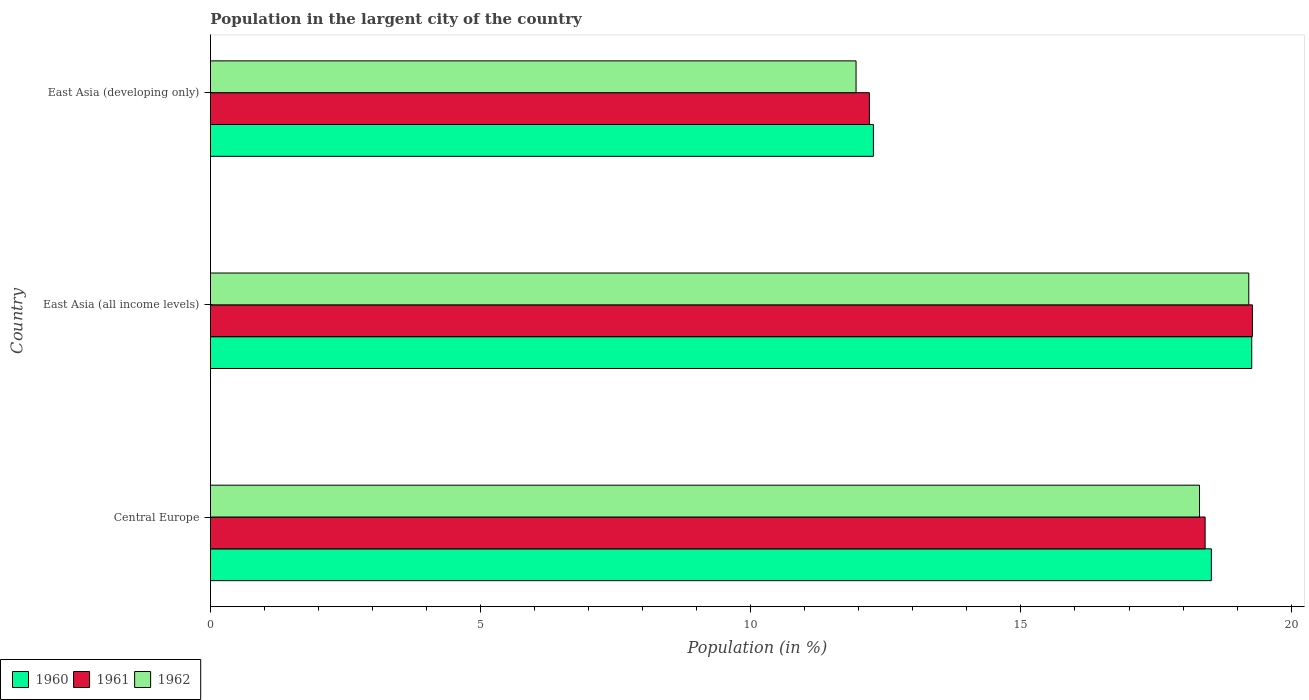How many different coloured bars are there?
Keep it short and to the point. 3. How many bars are there on the 3rd tick from the top?
Offer a terse response. 3. What is the label of the 2nd group of bars from the top?
Make the answer very short. East Asia (all income levels). In how many cases, is the number of bars for a given country not equal to the number of legend labels?
Offer a terse response. 0. What is the percentage of population in the largent city in 1962 in East Asia (developing only)?
Make the answer very short. 11.95. Across all countries, what is the maximum percentage of population in the largent city in 1960?
Give a very brief answer. 19.27. Across all countries, what is the minimum percentage of population in the largent city in 1962?
Keep it short and to the point. 11.95. In which country was the percentage of population in the largent city in 1960 maximum?
Give a very brief answer. East Asia (all income levels). In which country was the percentage of population in the largent city in 1961 minimum?
Ensure brevity in your answer.  East Asia (developing only). What is the total percentage of population in the largent city in 1961 in the graph?
Give a very brief answer. 49.89. What is the difference between the percentage of population in the largent city in 1960 in Central Europe and that in East Asia (developing only)?
Make the answer very short. 6.25. What is the difference between the percentage of population in the largent city in 1960 in East Asia (all income levels) and the percentage of population in the largent city in 1962 in Central Europe?
Your answer should be compact. 0.97. What is the average percentage of population in the largent city in 1961 per country?
Give a very brief answer. 16.63. What is the difference between the percentage of population in the largent city in 1961 and percentage of population in the largent city in 1962 in East Asia (all income levels)?
Your answer should be compact. 0.07. What is the ratio of the percentage of population in the largent city in 1962 in Central Europe to that in East Asia (all income levels)?
Your answer should be compact. 0.95. Is the difference between the percentage of population in the largent city in 1961 in Central Europe and East Asia (developing only) greater than the difference between the percentage of population in the largent city in 1962 in Central Europe and East Asia (developing only)?
Offer a very short reply. No. What is the difference between the highest and the second highest percentage of population in the largent city in 1960?
Ensure brevity in your answer.  0.75. What is the difference between the highest and the lowest percentage of population in the largent city in 1962?
Your answer should be compact. 7.27. In how many countries, is the percentage of population in the largent city in 1961 greater than the average percentage of population in the largent city in 1961 taken over all countries?
Your answer should be compact. 2. What does the 2nd bar from the top in East Asia (all income levels) represents?
Ensure brevity in your answer.  1961. What does the 3rd bar from the bottom in East Asia (all income levels) represents?
Offer a terse response. 1962. Are all the bars in the graph horizontal?
Your answer should be very brief. Yes. How many countries are there in the graph?
Your answer should be compact. 3. What is the difference between two consecutive major ticks on the X-axis?
Your answer should be compact. 5. Does the graph contain any zero values?
Offer a very short reply. No. Where does the legend appear in the graph?
Make the answer very short. Bottom left. How are the legend labels stacked?
Provide a short and direct response. Horizontal. What is the title of the graph?
Ensure brevity in your answer.  Population in the largent city of the country. Does "1990" appear as one of the legend labels in the graph?
Keep it short and to the point. No. What is the label or title of the X-axis?
Offer a very short reply. Population (in %). What is the Population (in %) in 1960 in Central Europe?
Provide a short and direct response. 18.52. What is the Population (in %) of 1961 in Central Europe?
Provide a succinct answer. 18.41. What is the Population (in %) in 1962 in Central Europe?
Your response must be concise. 18.31. What is the Population (in %) in 1960 in East Asia (all income levels)?
Keep it short and to the point. 19.27. What is the Population (in %) in 1961 in East Asia (all income levels)?
Ensure brevity in your answer.  19.28. What is the Population (in %) of 1962 in East Asia (all income levels)?
Give a very brief answer. 19.22. What is the Population (in %) of 1960 in East Asia (developing only)?
Your answer should be compact. 12.27. What is the Population (in %) of 1961 in East Asia (developing only)?
Offer a terse response. 12.2. What is the Population (in %) of 1962 in East Asia (developing only)?
Make the answer very short. 11.95. Across all countries, what is the maximum Population (in %) of 1960?
Keep it short and to the point. 19.27. Across all countries, what is the maximum Population (in %) in 1961?
Offer a very short reply. 19.28. Across all countries, what is the maximum Population (in %) of 1962?
Offer a very short reply. 19.22. Across all countries, what is the minimum Population (in %) in 1960?
Your answer should be very brief. 12.27. Across all countries, what is the minimum Population (in %) in 1961?
Offer a very short reply. 12.2. Across all countries, what is the minimum Population (in %) in 1962?
Your answer should be compact. 11.95. What is the total Population (in %) in 1960 in the graph?
Provide a short and direct response. 50.07. What is the total Population (in %) in 1961 in the graph?
Make the answer very short. 49.89. What is the total Population (in %) of 1962 in the graph?
Your answer should be compact. 49.47. What is the difference between the Population (in %) in 1960 in Central Europe and that in East Asia (all income levels)?
Your answer should be very brief. -0.75. What is the difference between the Population (in %) in 1961 in Central Europe and that in East Asia (all income levels)?
Ensure brevity in your answer.  -0.87. What is the difference between the Population (in %) in 1962 in Central Europe and that in East Asia (all income levels)?
Your response must be concise. -0.91. What is the difference between the Population (in %) in 1960 in Central Europe and that in East Asia (developing only)?
Provide a succinct answer. 6.25. What is the difference between the Population (in %) of 1961 in Central Europe and that in East Asia (developing only)?
Provide a succinct answer. 6.21. What is the difference between the Population (in %) in 1962 in Central Europe and that in East Asia (developing only)?
Give a very brief answer. 6.36. What is the difference between the Population (in %) in 1960 in East Asia (all income levels) and that in East Asia (developing only)?
Provide a succinct answer. 7. What is the difference between the Population (in %) of 1961 in East Asia (all income levels) and that in East Asia (developing only)?
Your answer should be compact. 7.09. What is the difference between the Population (in %) of 1962 in East Asia (all income levels) and that in East Asia (developing only)?
Make the answer very short. 7.27. What is the difference between the Population (in %) of 1960 in Central Europe and the Population (in %) of 1961 in East Asia (all income levels)?
Your response must be concise. -0.76. What is the difference between the Population (in %) of 1960 in Central Europe and the Population (in %) of 1962 in East Asia (all income levels)?
Offer a very short reply. -0.69. What is the difference between the Population (in %) in 1961 in Central Europe and the Population (in %) in 1962 in East Asia (all income levels)?
Provide a succinct answer. -0.81. What is the difference between the Population (in %) in 1960 in Central Europe and the Population (in %) in 1961 in East Asia (developing only)?
Make the answer very short. 6.33. What is the difference between the Population (in %) of 1960 in Central Europe and the Population (in %) of 1962 in East Asia (developing only)?
Keep it short and to the point. 6.58. What is the difference between the Population (in %) in 1961 in Central Europe and the Population (in %) in 1962 in East Asia (developing only)?
Ensure brevity in your answer.  6.46. What is the difference between the Population (in %) of 1960 in East Asia (all income levels) and the Population (in %) of 1961 in East Asia (developing only)?
Your answer should be compact. 7.08. What is the difference between the Population (in %) of 1960 in East Asia (all income levels) and the Population (in %) of 1962 in East Asia (developing only)?
Make the answer very short. 7.32. What is the difference between the Population (in %) in 1961 in East Asia (all income levels) and the Population (in %) in 1962 in East Asia (developing only)?
Your answer should be compact. 7.34. What is the average Population (in %) in 1960 per country?
Your answer should be very brief. 16.69. What is the average Population (in %) in 1961 per country?
Provide a short and direct response. 16.63. What is the average Population (in %) of 1962 per country?
Give a very brief answer. 16.49. What is the difference between the Population (in %) in 1960 and Population (in %) in 1961 in Central Europe?
Ensure brevity in your answer.  0.12. What is the difference between the Population (in %) of 1960 and Population (in %) of 1962 in Central Europe?
Your response must be concise. 0.22. What is the difference between the Population (in %) in 1961 and Population (in %) in 1962 in Central Europe?
Ensure brevity in your answer.  0.1. What is the difference between the Population (in %) in 1960 and Population (in %) in 1961 in East Asia (all income levels)?
Offer a terse response. -0.01. What is the difference between the Population (in %) of 1960 and Population (in %) of 1962 in East Asia (all income levels)?
Offer a very short reply. 0.05. What is the difference between the Population (in %) in 1961 and Population (in %) in 1962 in East Asia (all income levels)?
Your answer should be compact. 0.07. What is the difference between the Population (in %) of 1960 and Population (in %) of 1961 in East Asia (developing only)?
Provide a succinct answer. 0.07. What is the difference between the Population (in %) in 1960 and Population (in %) in 1962 in East Asia (developing only)?
Provide a succinct answer. 0.32. What is the difference between the Population (in %) of 1961 and Population (in %) of 1962 in East Asia (developing only)?
Your response must be concise. 0.25. What is the ratio of the Population (in %) in 1960 in Central Europe to that in East Asia (all income levels)?
Your answer should be compact. 0.96. What is the ratio of the Population (in %) in 1961 in Central Europe to that in East Asia (all income levels)?
Provide a short and direct response. 0.95. What is the ratio of the Population (in %) in 1962 in Central Europe to that in East Asia (all income levels)?
Provide a short and direct response. 0.95. What is the ratio of the Population (in %) in 1960 in Central Europe to that in East Asia (developing only)?
Offer a very short reply. 1.51. What is the ratio of the Population (in %) of 1961 in Central Europe to that in East Asia (developing only)?
Your answer should be very brief. 1.51. What is the ratio of the Population (in %) of 1962 in Central Europe to that in East Asia (developing only)?
Your response must be concise. 1.53. What is the ratio of the Population (in %) of 1960 in East Asia (all income levels) to that in East Asia (developing only)?
Provide a succinct answer. 1.57. What is the ratio of the Population (in %) of 1961 in East Asia (all income levels) to that in East Asia (developing only)?
Offer a terse response. 1.58. What is the ratio of the Population (in %) of 1962 in East Asia (all income levels) to that in East Asia (developing only)?
Offer a very short reply. 1.61. What is the difference between the highest and the second highest Population (in %) in 1960?
Make the answer very short. 0.75. What is the difference between the highest and the second highest Population (in %) of 1961?
Provide a short and direct response. 0.87. What is the difference between the highest and the second highest Population (in %) of 1962?
Provide a short and direct response. 0.91. What is the difference between the highest and the lowest Population (in %) of 1960?
Offer a very short reply. 7. What is the difference between the highest and the lowest Population (in %) in 1961?
Provide a short and direct response. 7.09. What is the difference between the highest and the lowest Population (in %) in 1962?
Give a very brief answer. 7.27. 